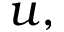<formula> <loc_0><loc_0><loc_500><loc_500>u ,</formula> 